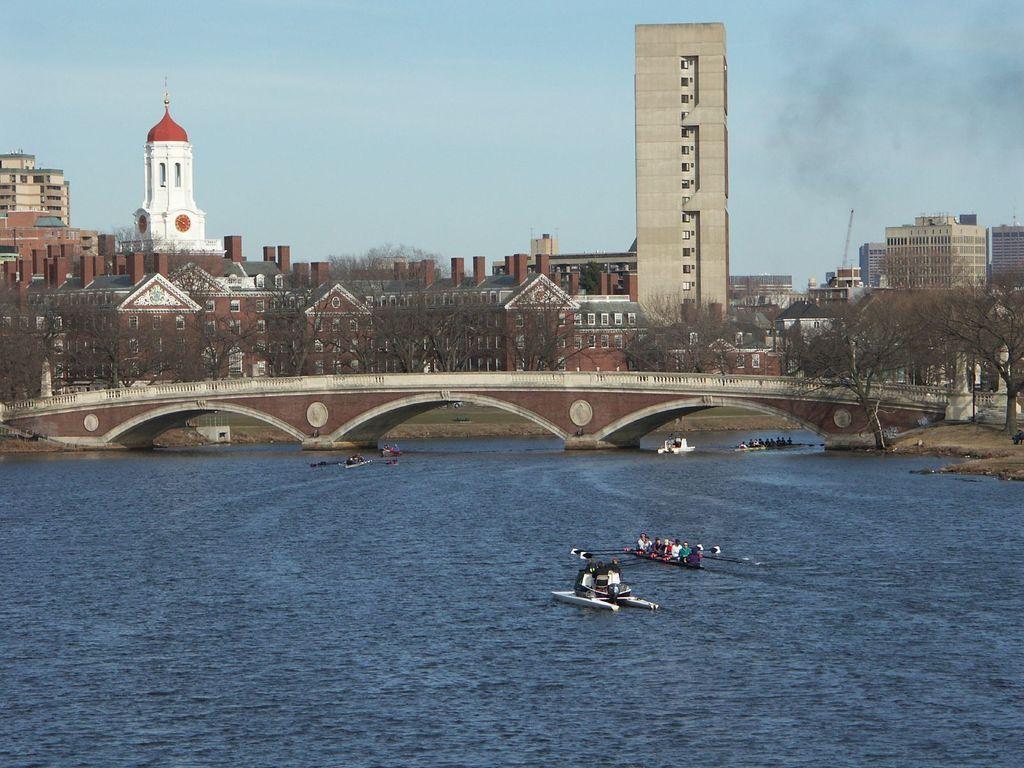Can you describe this image briefly? In this picture we can see boats on water, here we can see people, bridge and in the background we can see buildings, trees, sky. 